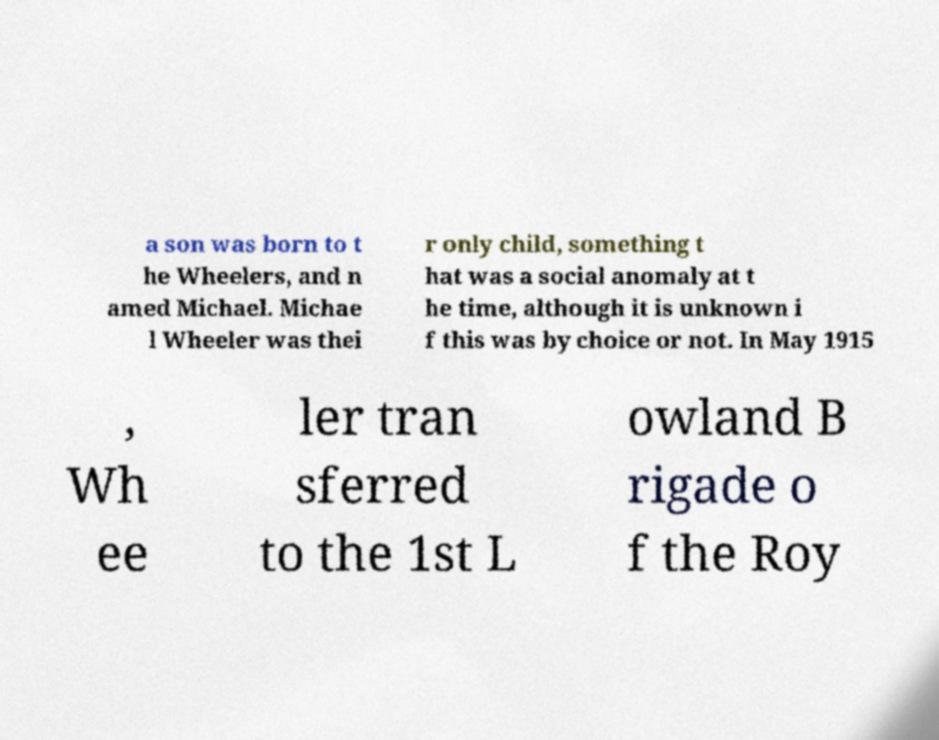Could you extract and type out the text from this image? a son was born to t he Wheelers, and n amed Michael. Michae l Wheeler was thei r only child, something t hat was a social anomaly at t he time, although it is unknown i f this was by choice or not. In May 1915 , Wh ee ler tran sferred to the 1st L owland B rigade o f the Roy 